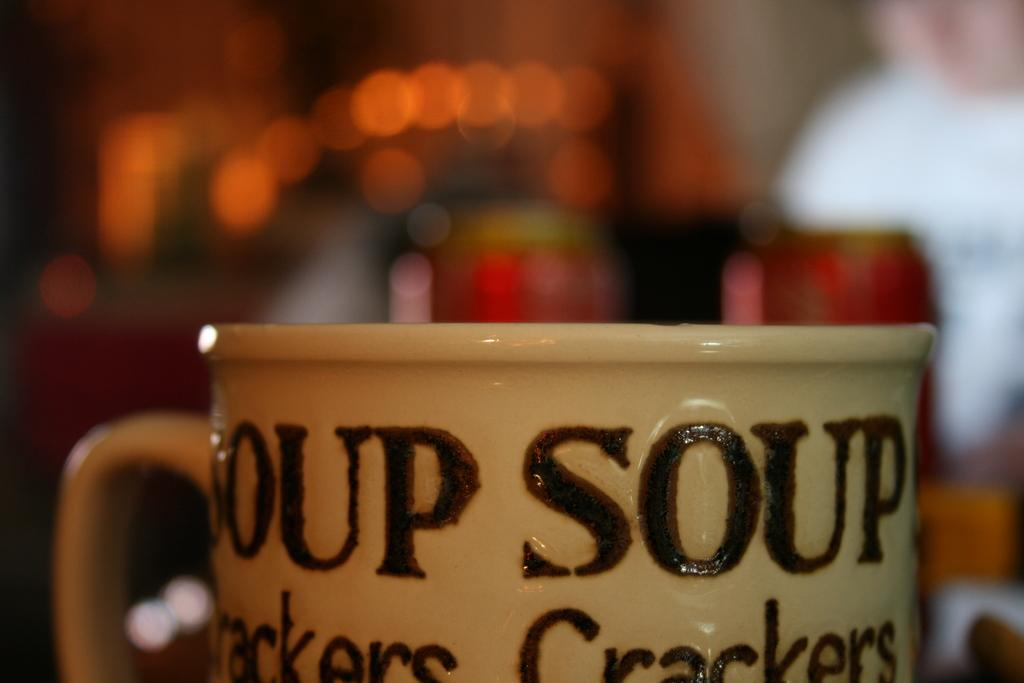What object is present in the image? There is a cup in the image. What color is the cup? The cup is cream-colored. What is written on the cup? The name "Soup Crackers" is written on the cup. How would you describe the background of the image? The background of the image is blurred. What type of coat is being used to stir the soup in the image? There is no soup or coat present in the image; it only features a cup with the name "Soup Crackers" written on it. 